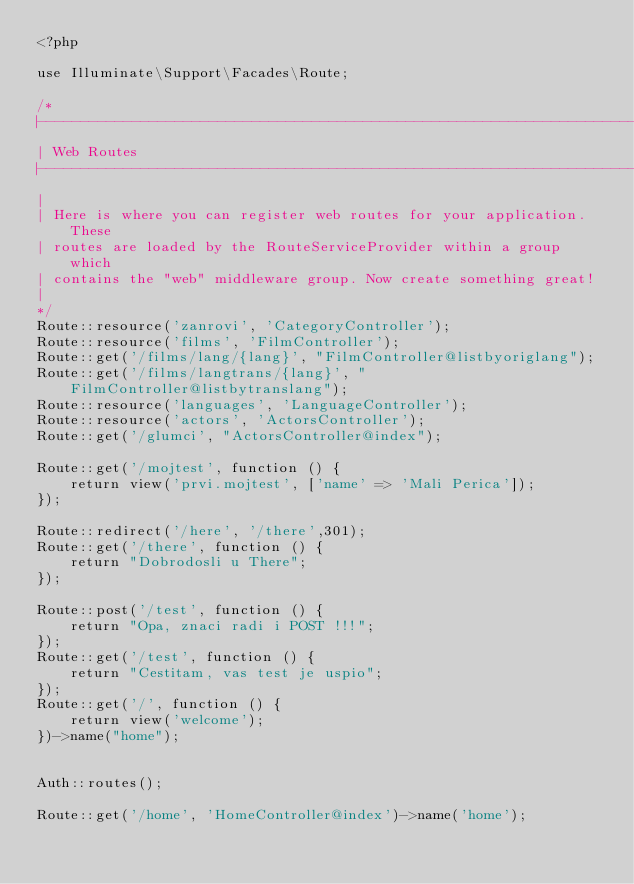<code> <loc_0><loc_0><loc_500><loc_500><_PHP_><?php

use Illuminate\Support\Facades\Route;

/*
|--------------------------------------------------------------------------
| Web Routes
|--------------------------------------------------------------------------
|
| Here is where you can register web routes for your application. These
| routes are loaded by the RouteServiceProvider within a group which
| contains the "web" middleware group. Now create something great!
|
*/
Route::resource('zanrovi', 'CategoryController');
Route::resource('films', 'FilmController');
Route::get('/films/lang/{lang}', "FilmController@listbyoriglang");
Route::get('/films/langtrans/{lang}', "FilmController@listbytranslang");
Route::resource('languages', 'LanguageController');
Route::resource('actors', 'ActorsController');
Route::get('/glumci', "ActorsController@index");

Route::get('/mojtest', function () {
    return view('prvi.mojtest', ['name' => 'Mali Perica']);
});

Route::redirect('/here', '/there',301);
Route::get('/there', function () {
    return "Dobrodosli u There";
});

Route::post('/test', function () {
    return "Opa, znaci radi i POST !!!";
});
Route::get('/test', function () {
    return "Cestitam, vas test je uspio";
});
Route::get('/', function () {
    return view('welcome');
})->name("home");


Auth::routes();

Route::get('/home', 'HomeController@index')->name('home');
</code> 